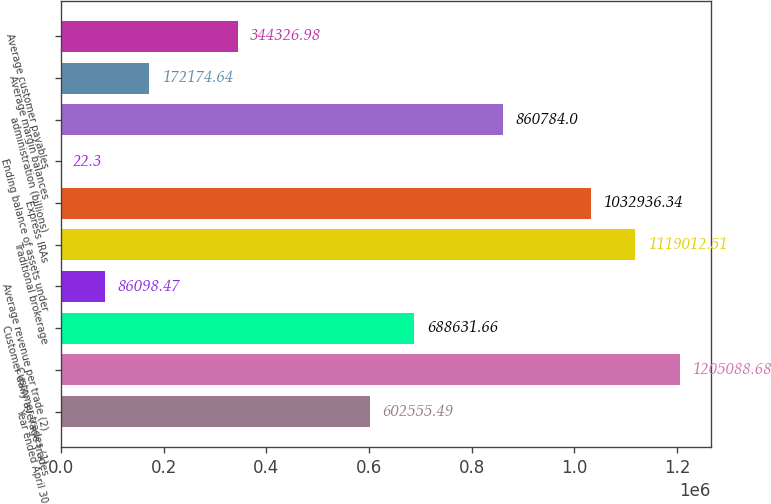<chart> <loc_0><loc_0><loc_500><loc_500><bar_chart><fcel>Year ended April 30<fcel>Customer trades (1)<fcel>Customer daily average trades<fcel>Average revenue per trade (2)<fcel>Traditional brokerage<fcel>Express IRAs<fcel>Ending balance of assets under<fcel>administration (billions)<fcel>Average margin balances<fcel>Average customer payables<nl><fcel>602555<fcel>1.20509e+06<fcel>688632<fcel>86098.5<fcel>1.11901e+06<fcel>1.03294e+06<fcel>22.3<fcel>860784<fcel>172175<fcel>344327<nl></chart> 